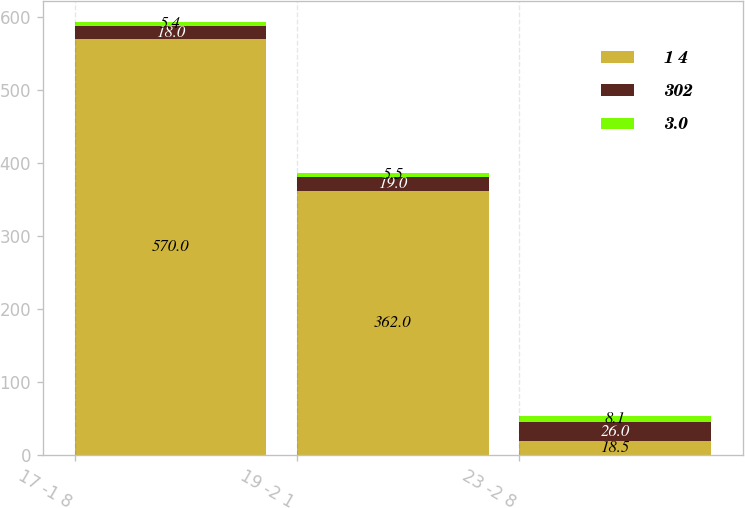<chart> <loc_0><loc_0><loc_500><loc_500><stacked_bar_chart><ecel><fcel>17 -1 8<fcel>19 -2 1<fcel>23 -2 8<nl><fcel>1 4<fcel>570<fcel>362<fcel>18.5<nl><fcel>302<fcel>18<fcel>19<fcel>26<nl><fcel>3.0<fcel>5.4<fcel>5.5<fcel>8.1<nl></chart> 